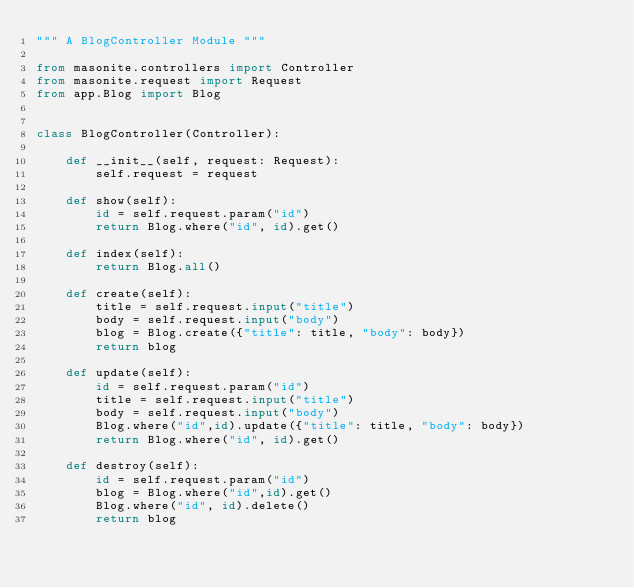<code> <loc_0><loc_0><loc_500><loc_500><_Python_>""" A BlogController Module """

from masonite.controllers import Controller
from masonite.request import Request
from app.Blog import Blog


class BlogController(Controller):
    
    def __init__(self, request: Request):
        self.request = request

    def show(self):
        id = self.request.param("id")
        return Blog.where("id", id).get()

    def index(self):
        return Blog.all()

    def create(self):
        title = self.request.input("title")
        body = self.request.input("body")
        blog = Blog.create({"title": title, "body": body})
        return blog

    def update(self):
        id = self.request.param("id")
        title = self.request.input("title")
        body = self.request.input("body")
        Blog.where("id",id).update({"title": title, "body": body})
        return Blog.where("id", id).get()

    def destroy(self):
        id = self.request.param("id")
        blog = Blog.where("id",id).get()
        Blog.where("id", id).delete()
        return blog</code> 